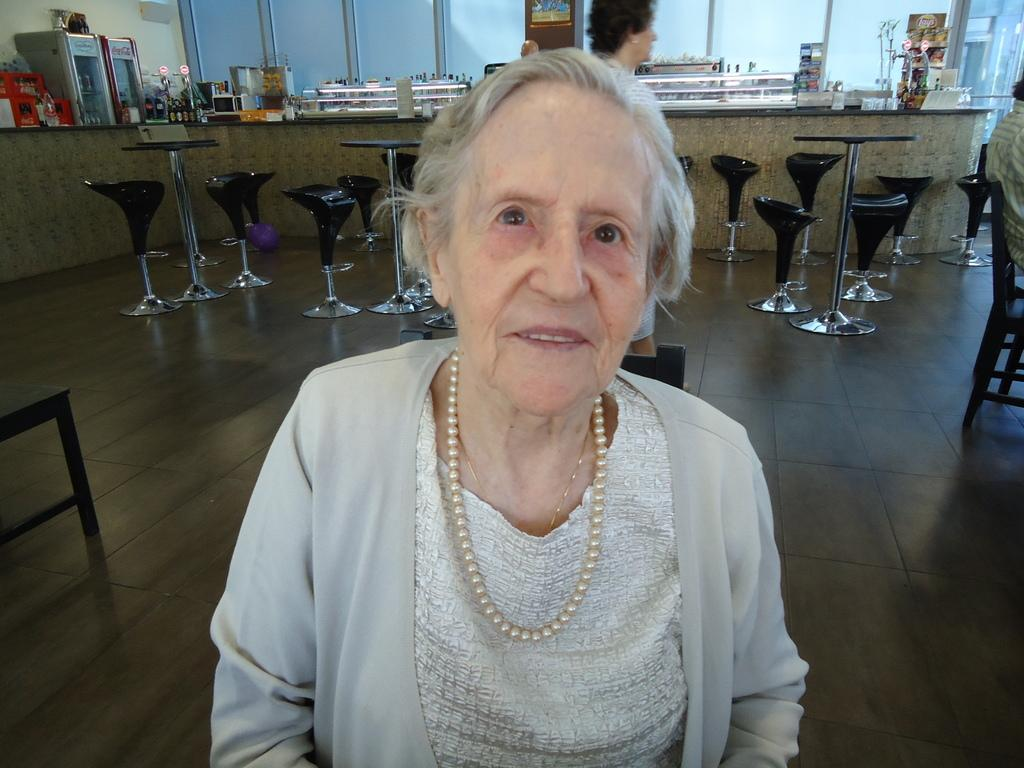Who or what can be seen in the image? There are people in the image. What are the people sitting on in the image? There are chairs on the floor in the image. Can you describe any objects present in the image? There are objects in the image, but their specific nature is not mentioned in the provided facts. What type of approval is being given by the person with fangs in the image? There is no person with fangs present in the image, and therefore no approval can be given by such a person. 